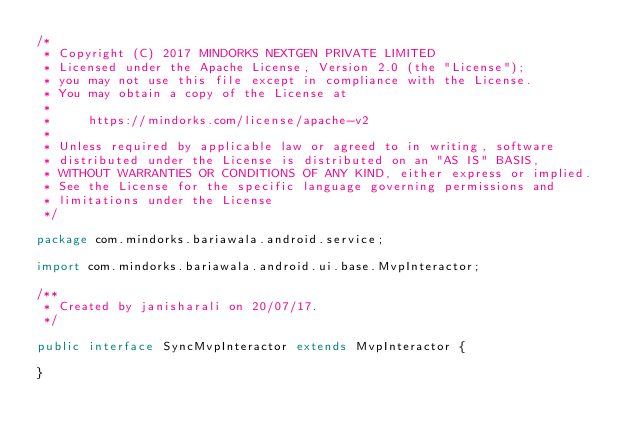Convert code to text. <code><loc_0><loc_0><loc_500><loc_500><_Java_>/*
 * Copyright (C) 2017 MINDORKS NEXTGEN PRIVATE LIMITED
 * Licensed under the Apache License, Version 2.0 (the "License");
 * you may not use this file except in compliance with the License.
 * You may obtain a copy of the License at
 *
 *     https://mindorks.com/license/apache-v2
 *
 * Unless required by applicable law or agreed to in writing, software
 * distributed under the License is distributed on an "AS IS" BASIS,
 * WITHOUT WARRANTIES OR CONDITIONS OF ANY KIND, either express or implied.
 * See the License for the specific language governing permissions and
 * limitations under the License
 */

package com.mindorks.bariawala.android.service;

import com.mindorks.bariawala.android.ui.base.MvpInteractor;

/**
 * Created by janisharali on 20/07/17.
 */

public interface SyncMvpInteractor extends MvpInteractor {

}
</code> 